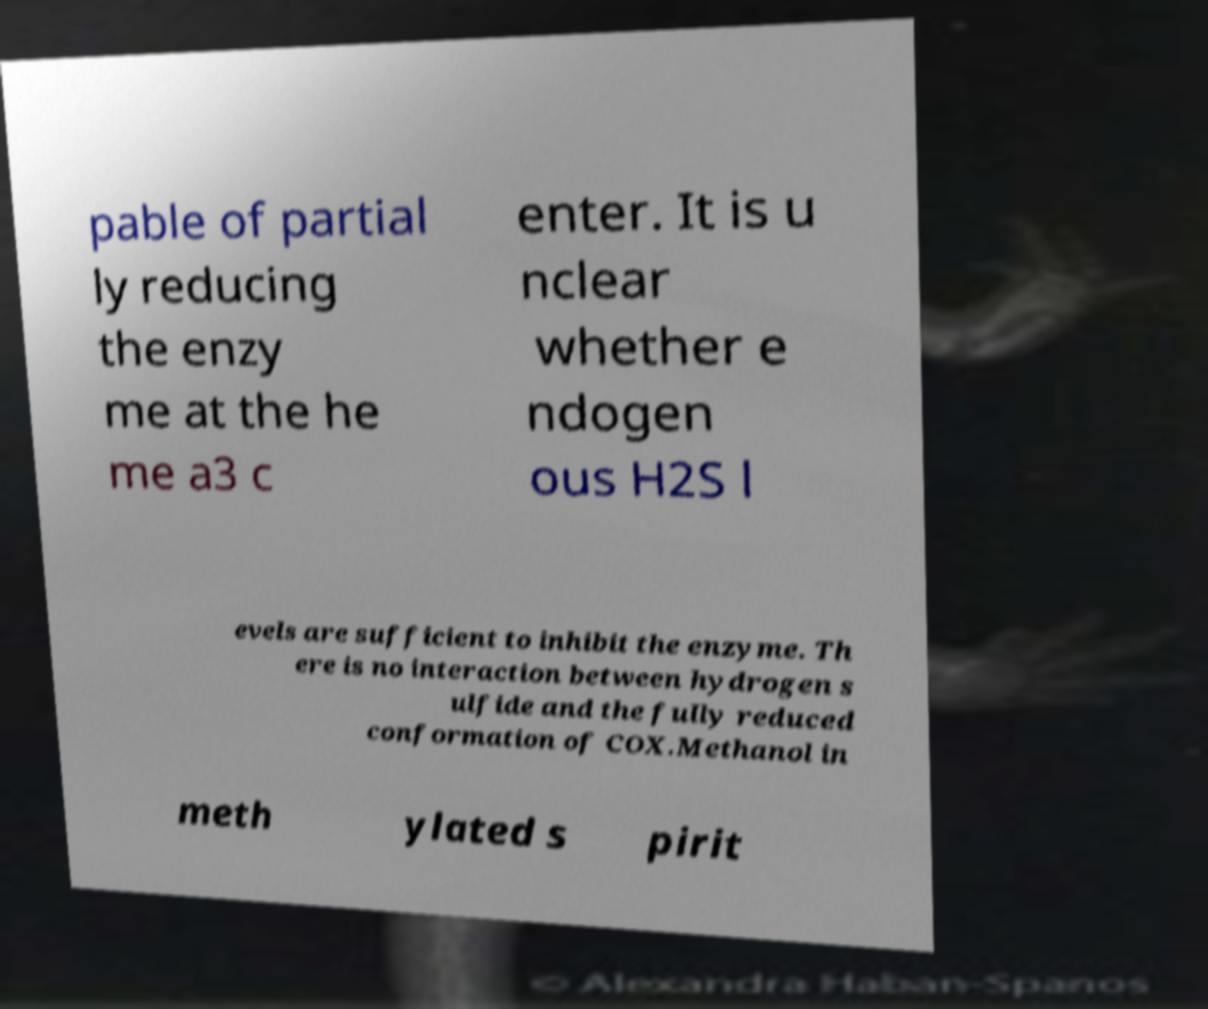For documentation purposes, I need the text within this image transcribed. Could you provide that? pable of partial ly reducing the enzy me at the he me a3 c enter. It is u nclear whether e ndogen ous H2S l evels are sufficient to inhibit the enzyme. Th ere is no interaction between hydrogen s ulfide and the fully reduced conformation of COX.Methanol in meth ylated s pirit 